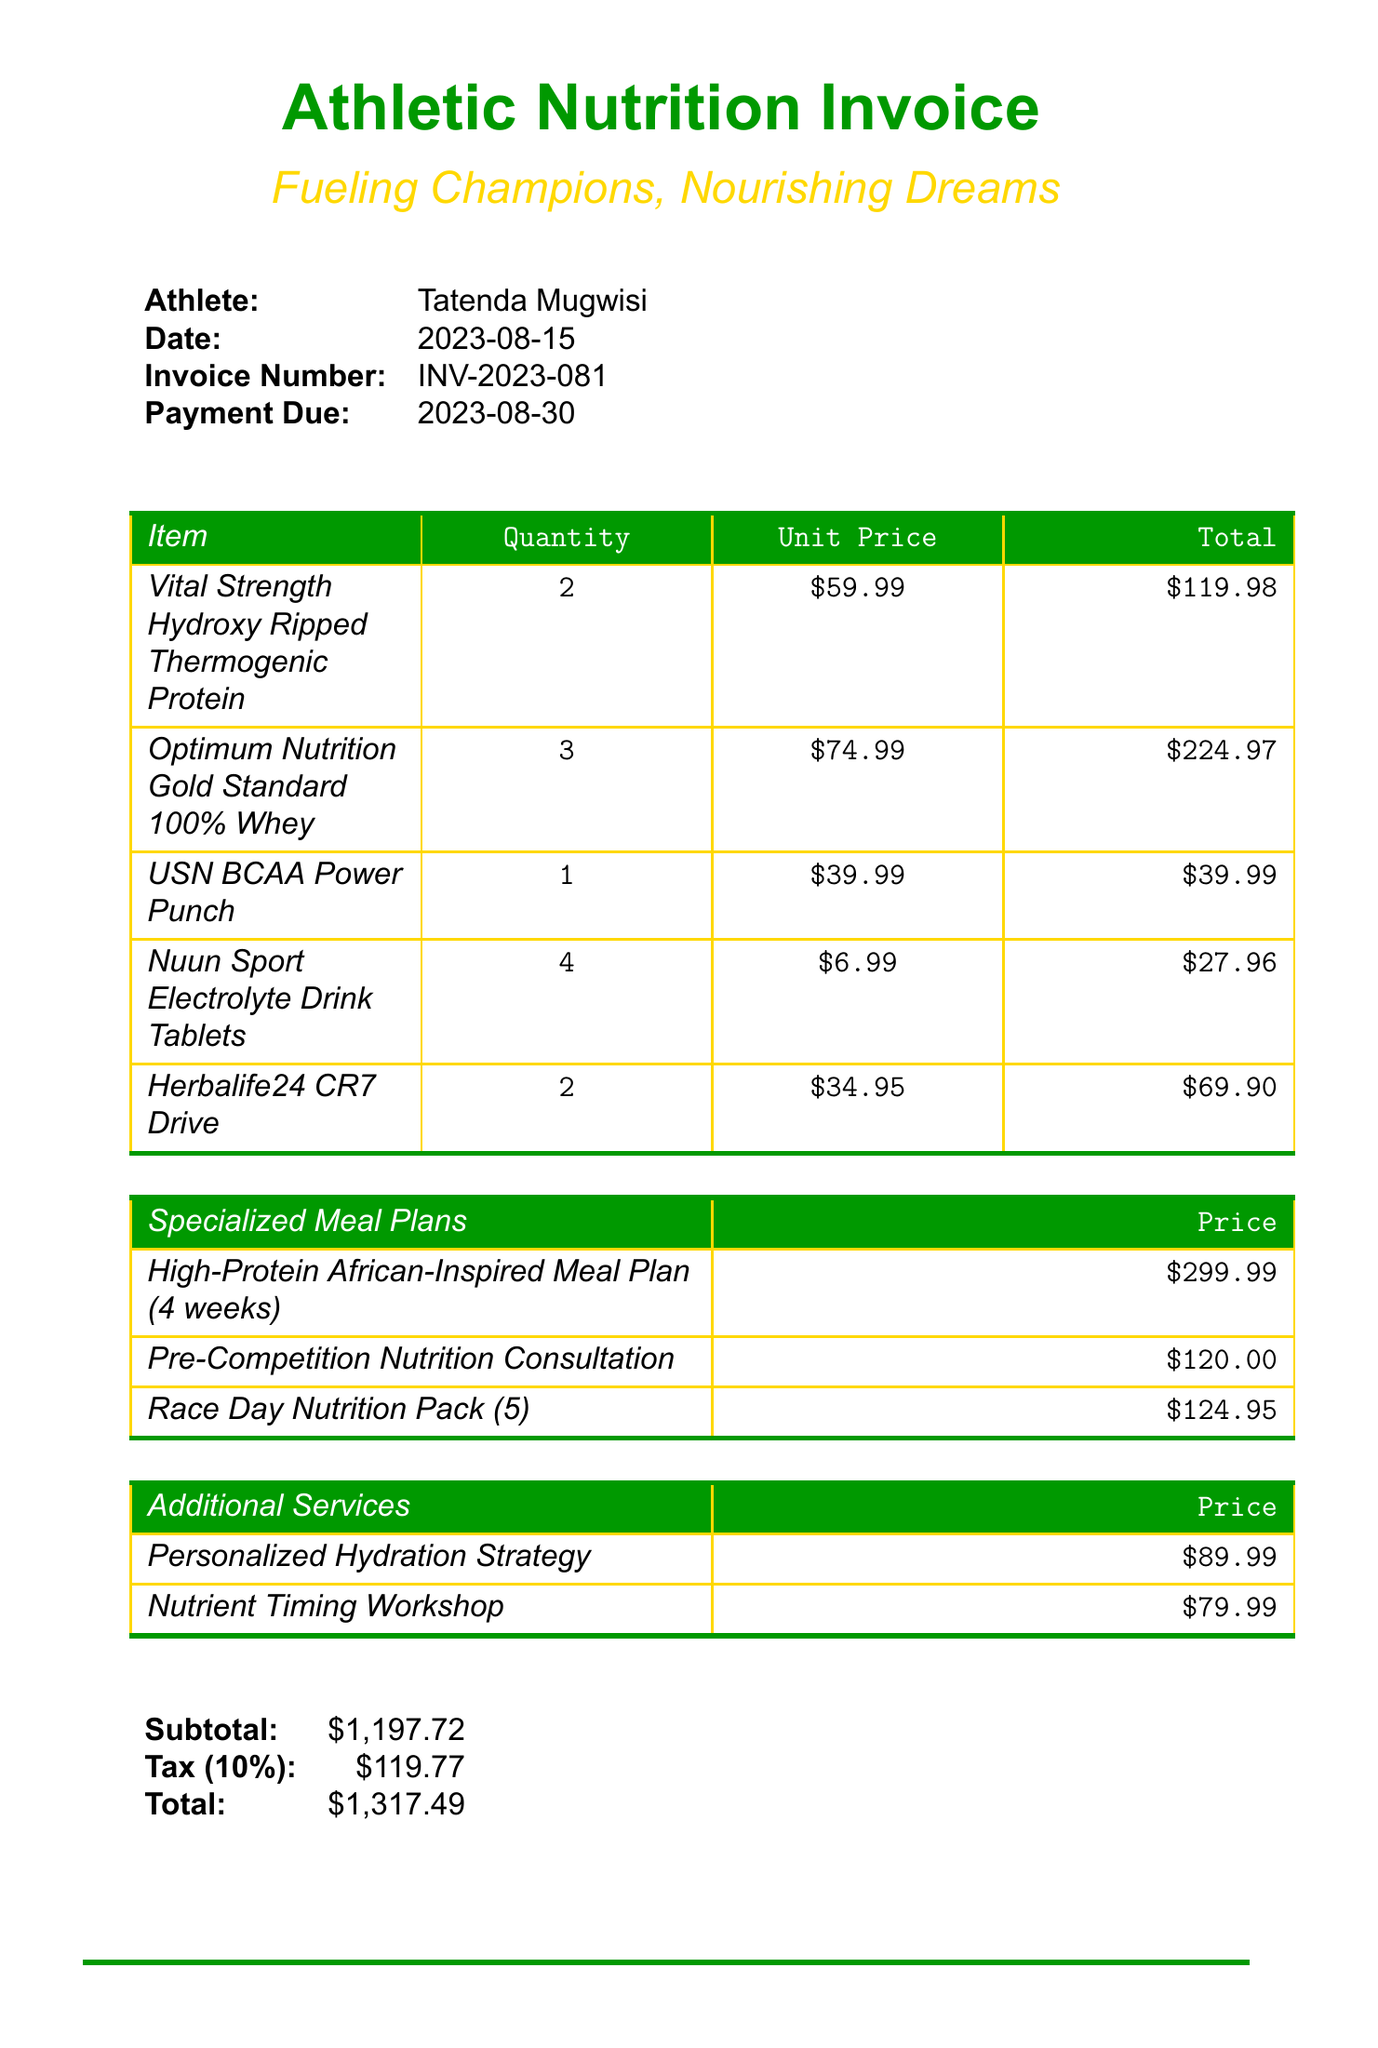What is the athlete's name? The athlete's name listed in the document is Tatenda Mugwisi.
Answer: Tatenda Mugwisi What is the total amount due? The total amount due is specified in the document under totals, which includes taxes.
Answer: $1,317.49 When is the payment due? The payment due date is explicitly mentioned in the document.
Answer: 2023-08-30 How many units of the USN BCAA Power Punch were purchased? The quantity of the USN BCAA Power Punch item is specified in the nutritional supplements section.
Answer: 1 What is the price of the High-Protein African-Inspired Meal Plan? The price for the specified meal plan is detailed in the specialized meal plans section.
Answer: $299.99 What service is tailored for high-altitude training? The document mentions a specific service designed for high-altitude training, found in the additional services section.
Answer: Personalized Hydration Strategy What is the unit price of Herbalife24 CR7 Drive? The unit price for the Herbalife24 CR7 Drive can be found in the nutritional supplements section.
Answer: $34.95 How many energy gels are included in the Race Day Nutrition Pack? The document specifies the quantity of items in the Race Day Nutrition Pack.
Answer: 5 What tax amount is included in the total? The tax is explicitly stated under the totals section of the document.
Answer: $119.77 